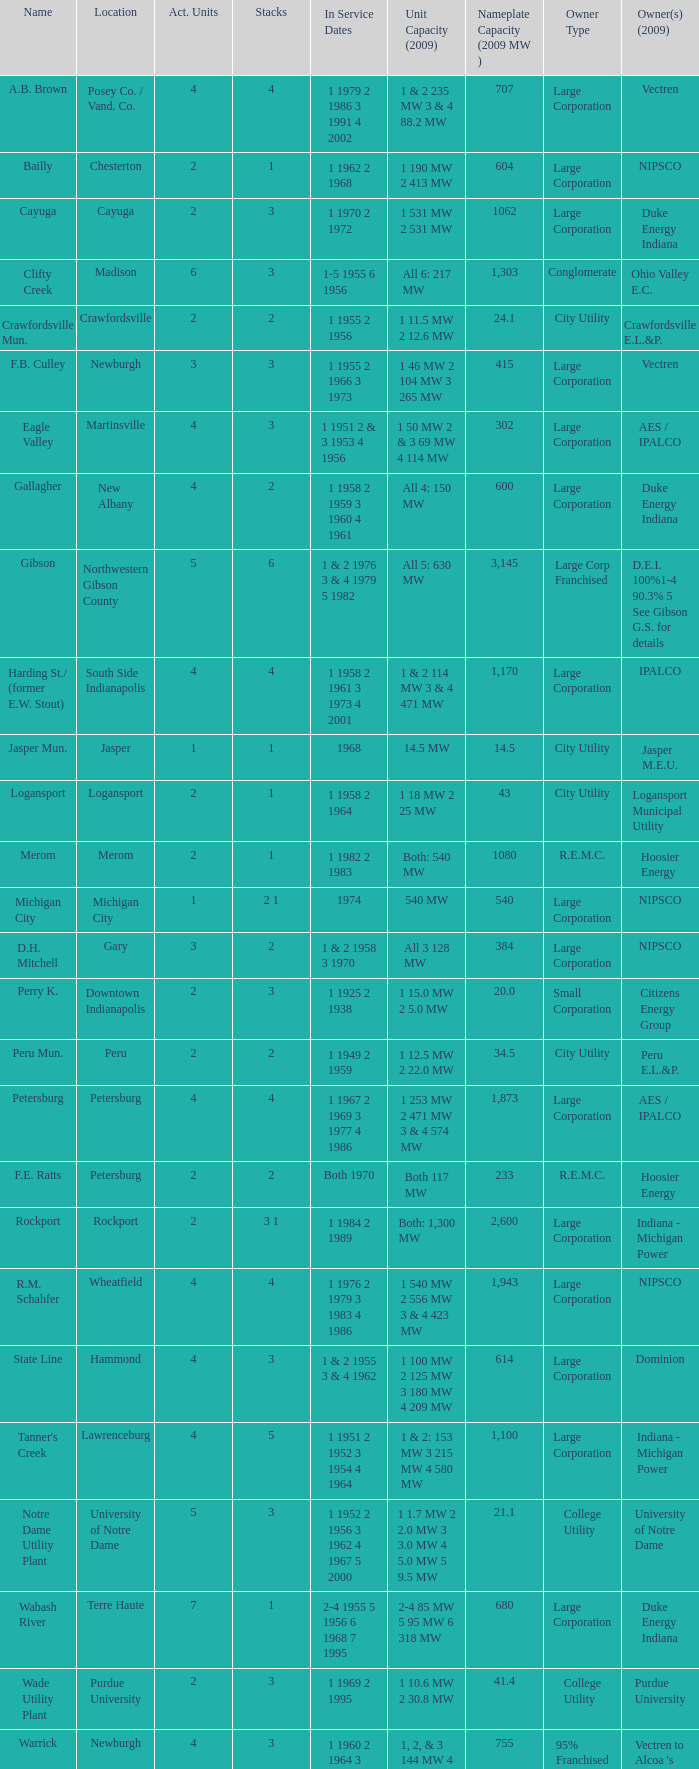Identify the proprietors in 2009 for the southern part of indianapolis. IPALCO. Would you be able to parse every entry in this table? {'header': ['Name', 'Location', 'Act. Units', 'Stacks', 'In Service Dates', 'Unit Capacity (2009)', 'Nameplate Capacity (2009 MW )', 'Owner Type', 'Owner(s) (2009)'], 'rows': [['A.B. Brown', 'Posey Co. / Vand. Co.', '4', '4', '1 1979 2 1986 3 1991 4 2002', '1 & 2 235 MW 3 & 4 88.2 MW', '707', 'Large Corporation', 'Vectren'], ['Bailly', 'Chesterton', '2', '1', '1 1962 2 1968', '1 190 MW 2 413 MW', '604', 'Large Corporation', 'NIPSCO'], ['Cayuga', 'Cayuga', '2', '3', '1 1970 2 1972', '1 531 MW 2 531 MW', '1062', 'Large Corporation', 'Duke Energy Indiana'], ['Clifty Creek', 'Madison', '6', '3', '1-5 1955 6 1956', 'All 6: 217 MW', '1,303', 'Conglomerate', 'Ohio Valley E.C.'], ['Crawfordsville Mun.', 'Crawfordsville', '2', '2', '1 1955 2 1956', '1 11.5 MW 2 12.6 MW', '24.1', 'City Utility', 'Crawfordsville E.L.&P.'], ['F.B. Culley', 'Newburgh', '3', '3', '1 1955 2 1966 3 1973', '1 46 MW 2 104 MW 3 265 MW', '415', 'Large Corporation', 'Vectren'], ['Eagle Valley', 'Martinsville', '4', '3', '1 1951 2 & 3 1953 4 1956', '1 50 MW 2 & 3 69 MW 4 114 MW', '302', 'Large Corporation', 'AES / IPALCO'], ['Gallagher', 'New Albany', '4', '2', '1 1958 2 1959 3 1960 4 1961', 'All 4: 150 MW', '600', 'Large Corporation', 'Duke Energy Indiana'], ['Gibson', 'Northwestern Gibson County', '5', '6', '1 & 2 1976 3 & 4 1979 5 1982', 'All 5: 630 MW', '3,145', 'Large Corp Franchised', 'D.E.I. 100%1-4 90.3% 5 See Gibson G.S. for details'], ['Harding St./ (former E.W. Stout)', 'South Side Indianapolis', '4', '4', '1 1958 2 1961 3 1973 4 2001', '1 & 2 114 MW 3 & 4 471 MW', '1,170', 'Large Corporation', 'IPALCO'], ['Jasper Mun.', 'Jasper', '1', '1', '1968', '14.5 MW', '14.5', 'City Utility', 'Jasper M.E.U.'], ['Logansport', 'Logansport', '2', '1', '1 1958 2 1964', '1 18 MW 2 25 MW', '43', 'City Utility', 'Logansport Municipal Utility'], ['Merom', 'Merom', '2', '1', '1 1982 2 1983', 'Both: 540 MW', '1080', 'R.E.M.C.', 'Hoosier Energy'], ['Michigan City', 'Michigan City', '1', '2 1', '1974', '540 MW', '540', 'Large Corporation', 'NIPSCO'], ['D.H. Mitchell', 'Gary', '3', '2', '1 & 2 1958 3 1970', 'All 3 128 MW', '384', 'Large Corporation', 'NIPSCO'], ['Perry K.', 'Downtown Indianapolis', '2', '3', '1 1925 2 1938', '1 15.0 MW 2 5.0 MW', '20.0', 'Small Corporation', 'Citizens Energy Group'], ['Peru Mun.', 'Peru', '2', '2', '1 1949 2 1959', '1 12.5 MW 2 22.0 MW', '34.5', 'City Utility', 'Peru E.L.&P.'], ['Petersburg', 'Petersburg', '4', '4', '1 1967 2 1969 3 1977 4 1986', '1 253 MW 2 471 MW 3 & 4 574 MW', '1,873', 'Large Corporation', 'AES / IPALCO'], ['F.E. Ratts', 'Petersburg', '2', '2', 'Both 1970', 'Both 117 MW', '233', 'R.E.M.C.', 'Hoosier Energy'], ['Rockport', 'Rockport', '2', '3 1', '1 1984 2 1989', 'Both: 1,300 MW', '2,600', 'Large Corporation', 'Indiana - Michigan Power'], ['R.M. Schahfer', 'Wheatfield', '4', '4', '1 1976 2 1979 3 1983 4 1986', '1 540 MW 2 556 MW 3 & 4 423 MW', '1,943', 'Large Corporation', 'NIPSCO'], ['State Line', 'Hammond', '4', '3', '1 & 2 1955 3 & 4 1962', '1 100 MW 2 125 MW 3 180 MW 4 209 MW', '614', 'Large Corporation', 'Dominion'], ["Tanner's Creek", 'Lawrenceburg', '4', '5', '1 1951 2 1952 3 1954 4 1964', '1 & 2: 153 MW 3 215 MW 4 580 MW', '1,100', 'Large Corporation', 'Indiana - Michigan Power'], ['Notre Dame Utility Plant', 'University of Notre Dame', '5', '3', '1 1952 2 1956 3 1962 4 1967 5 2000', '1 1.7 MW 2 2.0 MW 3 3.0 MW 4 5.0 MW 5 9.5 MW', '21.1', 'College Utility', 'University of Notre Dame'], ['Wabash River', 'Terre Haute', '7', '1', '2-4 1955 5 1956 6 1968 7 1995', '2-4 85 MW 5 95 MW 6 318 MW', '680', 'Large Corporation', 'Duke Energy Indiana'], ['Wade Utility Plant', 'Purdue University', '2', '3', '1 1969 2 1995', '1 10.6 MW 2 30.8 MW', '41.4', 'College Utility', 'Purdue University'], ['Warrick', 'Newburgh', '4', '3', '1 1960 2 1964 3 1965 4 1970', '1, 2, & 3 144 MW 4 323 MW', '755', '95% Franchised', "Vectren to Alcoa 's Newburgh Smelter"]]} 